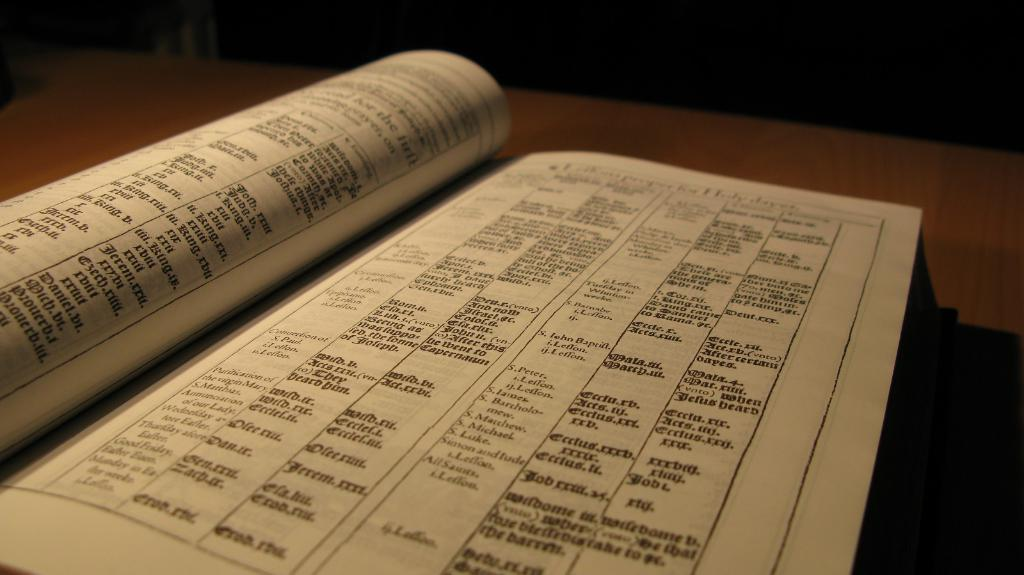What object is in the center of the image? There is a book in the center of the image. Where is the book located? The book is on a table. What type of cake is being used to lock the book in the image? There is no cake or lock present in the image; it only features a book on a table. 